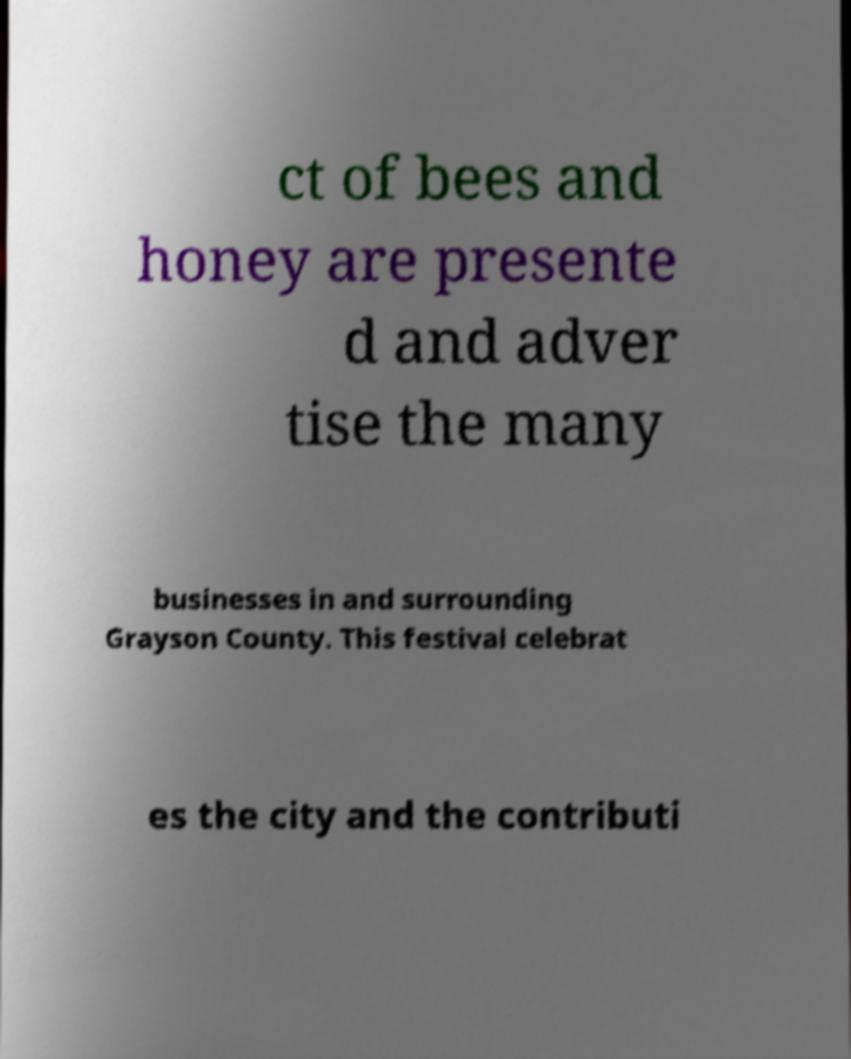I need the written content from this picture converted into text. Can you do that? ct of bees and honey are presente d and adver tise the many businesses in and surrounding Grayson County. This festival celebrat es the city and the contributi 